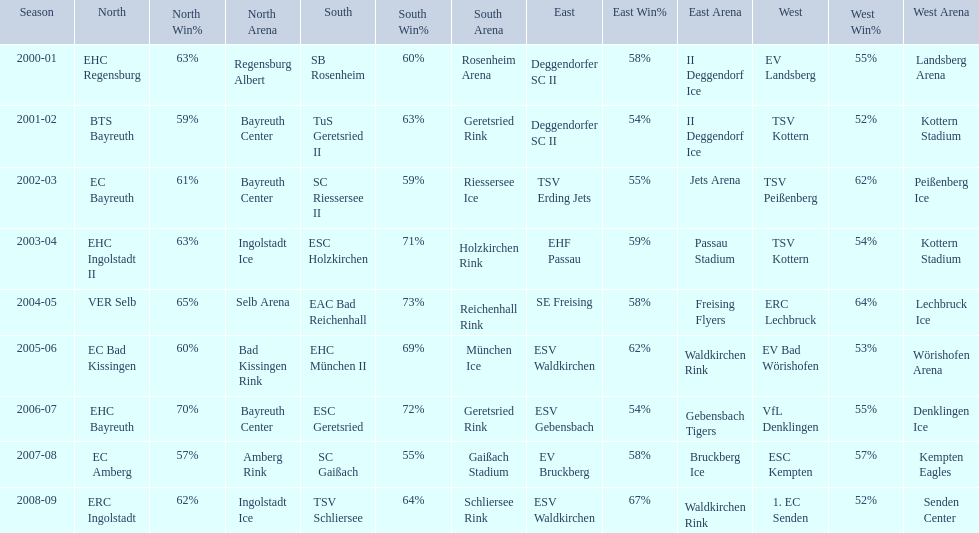Which teams won the north in their respective years? 2000-01, EHC Regensburg, BTS Bayreuth, EC Bayreuth, EHC Ingolstadt II, VER Selb, EC Bad Kissingen, EHC Bayreuth, EC Amberg, ERC Ingolstadt. Which one only won in 2000-01? EHC Regensburg. 